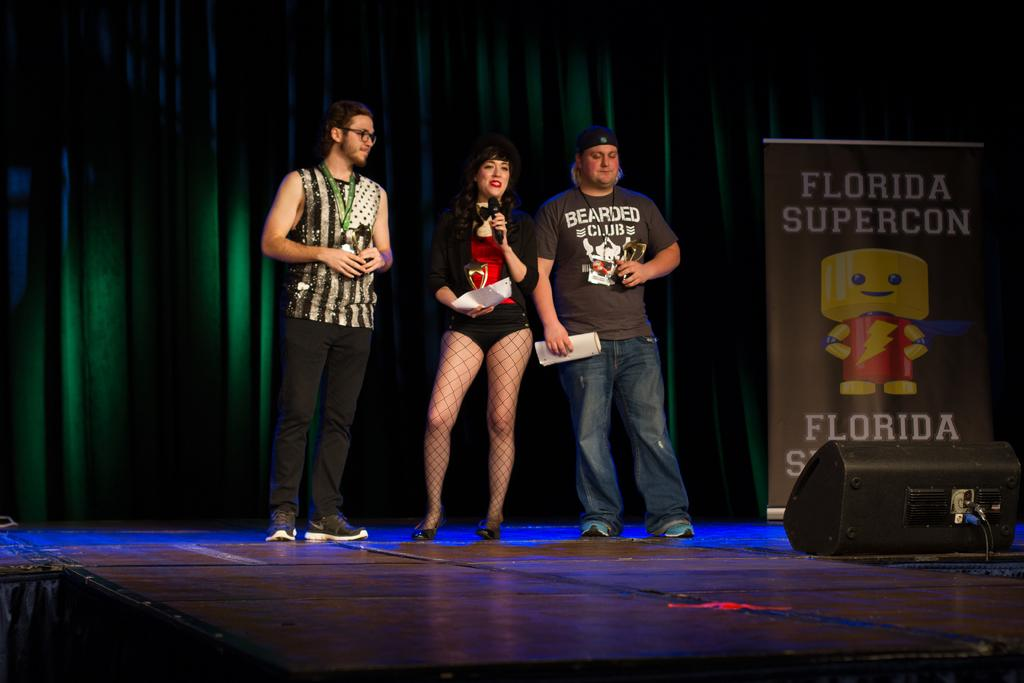<image>
Write a terse but informative summary of the picture. Two men with a woman in the middle are on a stage with a sign that says Florida Supercon on the right. 